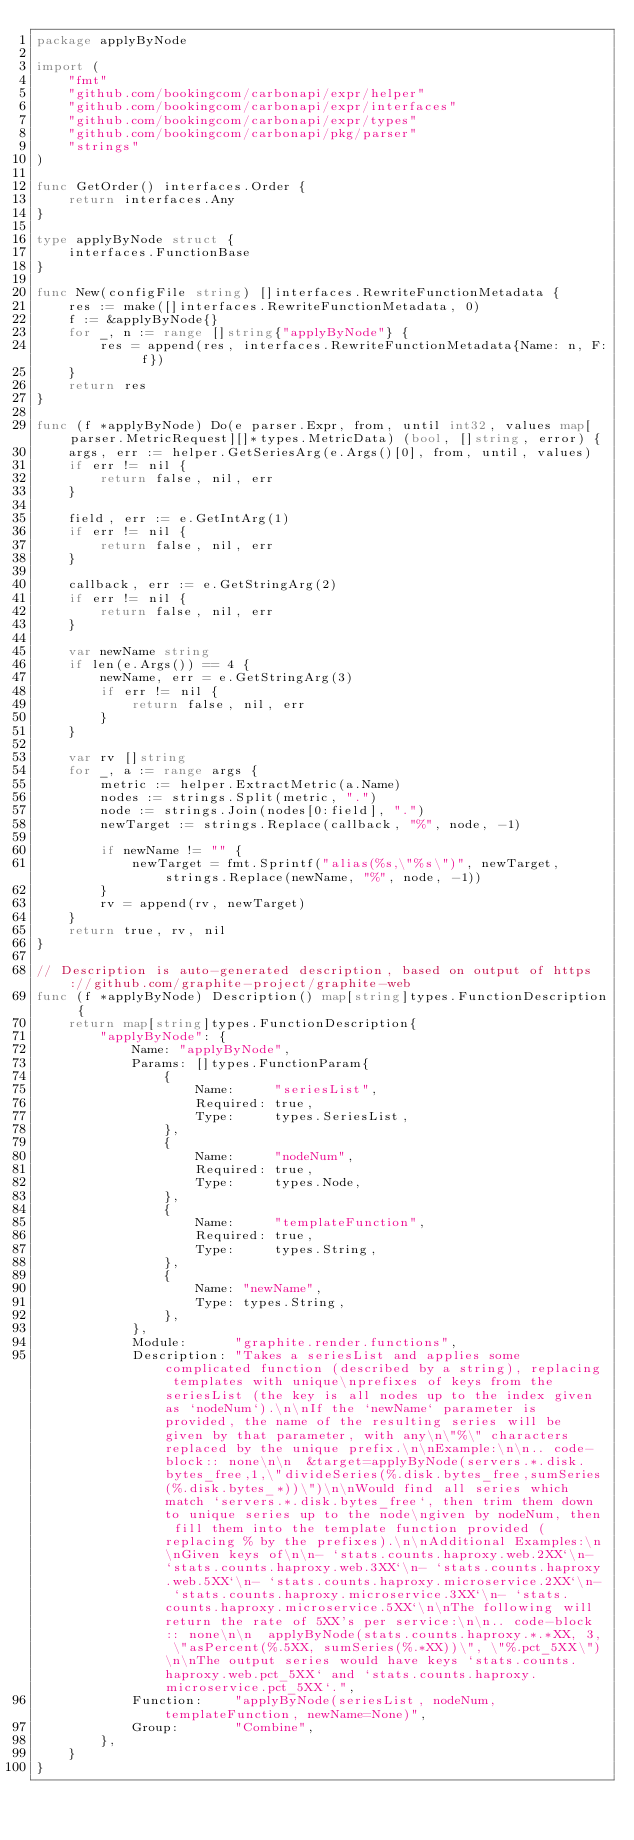Convert code to text. <code><loc_0><loc_0><loc_500><loc_500><_Go_>package applyByNode

import (
	"fmt"
	"github.com/bookingcom/carbonapi/expr/helper"
	"github.com/bookingcom/carbonapi/expr/interfaces"
	"github.com/bookingcom/carbonapi/expr/types"
	"github.com/bookingcom/carbonapi/pkg/parser"
	"strings"
)

func GetOrder() interfaces.Order {
	return interfaces.Any
}

type applyByNode struct {
	interfaces.FunctionBase
}

func New(configFile string) []interfaces.RewriteFunctionMetadata {
	res := make([]interfaces.RewriteFunctionMetadata, 0)
	f := &applyByNode{}
	for _, n := range []string{"applyByNode"} {
		res = append(res, interfaces.RewriteFunctionMetadata{Name: n, F: f})
	}
	return res
}

func (f *applyByNode) Do(e parser.Expr, from, until int32, values map[parser.MetricRequest][]*types.MetricData) (bool, []string, error) {
	args, err := helper.GetSeriesArg(e.Args()[0], from, until, values)
	if err != nil {
		return false, nil, err
	}

	field, err := e.GetIntArg(1)
	if err != nil {
		return false, nil, err
	}

	callback, err := e.GetStringArg(2)
	if err != nil {
		return false, nil, err
	}

	var newName string
	if len(e.Args()) == 4 {
		newName, err = e.GetStringArg(3)
		if err != nil {
			return false, nil, err
		}
	}

	var rv []string
	for _, a := range args {
		metric := helper.ExtractMetric(a.Name)
		nodes := strings.Split(metric, ".")
		node := strings.Join(nodes[0:field], ".")
		newTarget := strings.Replace(callback, "%", node, -1)

		if newName != "" {
			newTarget = fmt.Sprintf("alias(%s,\"%s\")", newTarget, strings.Replace(newName, "%", node, -1))
		}
		rv = append(rv, newTarget)
	}
	return true, rv, nil
}

// Description is auto-generated description, based on output of https://github.com/graphite-project/graphite-web
func (f *applyByNode) Description() map[string]types.FunctionDescription {
	return map[string]types.FunctionDescription{
		"applyByNode": {
			Name: "applyByNode",
			Params: []types.FunctionParam{
				{
					Name:     "seriesList",
					Required: true,
					Type:     types.SeriesList,
				},
				{
					Name:     "nodeNum",
					Required: true,
					Type:     types.Node,
				},
				{
					Name:     "templateFunction",
					Required: true,
					Type:     types.String,
				},
				{
					Name: "newName",
					Type: types.String,
				},
			},
			Module:      "graphite.render.functions",
			Description: "Takes a seriesList and applies some complicated function (described by a string), replacing templates with unique\nprefixes of keys from the seriesList (the key is all nodes up to the index given as `nodeNum`).\n\nIf the `newName` parameter is provided, the name of the resulting series will be given by that parameter, with any\n\"%\" characters replaced by the unique prefix.\n\nExample:\n\n.. code-block:: none\n\n  &target=applyByNode(servers.*.disk.bytes_free,1,\"divideSeries(%.disk.bytes_free,sumSeries(%.disk.bytes_*))\")\n\nWould find all series which match `servers.*.disk.bytes_free`, then trim them down to unique series up to the node\ngiven by nodeNum, then fill them into the template function provided (replacing % by the prefixes).\n\nAdditional Examples:\n\nGiven keys of\n\n- `stats.counts.haproxy.web.2XX`\n- `stats.counts.haproxy.web.3XX`\n- `stats.counts.haproxy.web.5XX`\n- `stats.counts.haproxy.microservice.2XX`\n- `stats.counts.haproxy.microservice.3XX`\n- `stats.counts.haproxy.microservice.5XX`\n\nThe following will return the rate of 5XX's per service:\n\n.. code-block:: none\n\n  applyByNode(stats.counts.haproxy.*.*XX, 3, \"asPercent(%.5XX, sumSeries(%.*XX))\", \"%.pct_5XX\")\n\nThe output series would have keys `stats.counts.haproxy.web.pct_5XX` and `stats.counts.haproxy.microservice.pct_5XX`.",
			Function:    "applyByNode(seriesList, nodeNum, templateFunction, newName=None)",
			Group:       "Combine",
		},
	}
}
</code> 